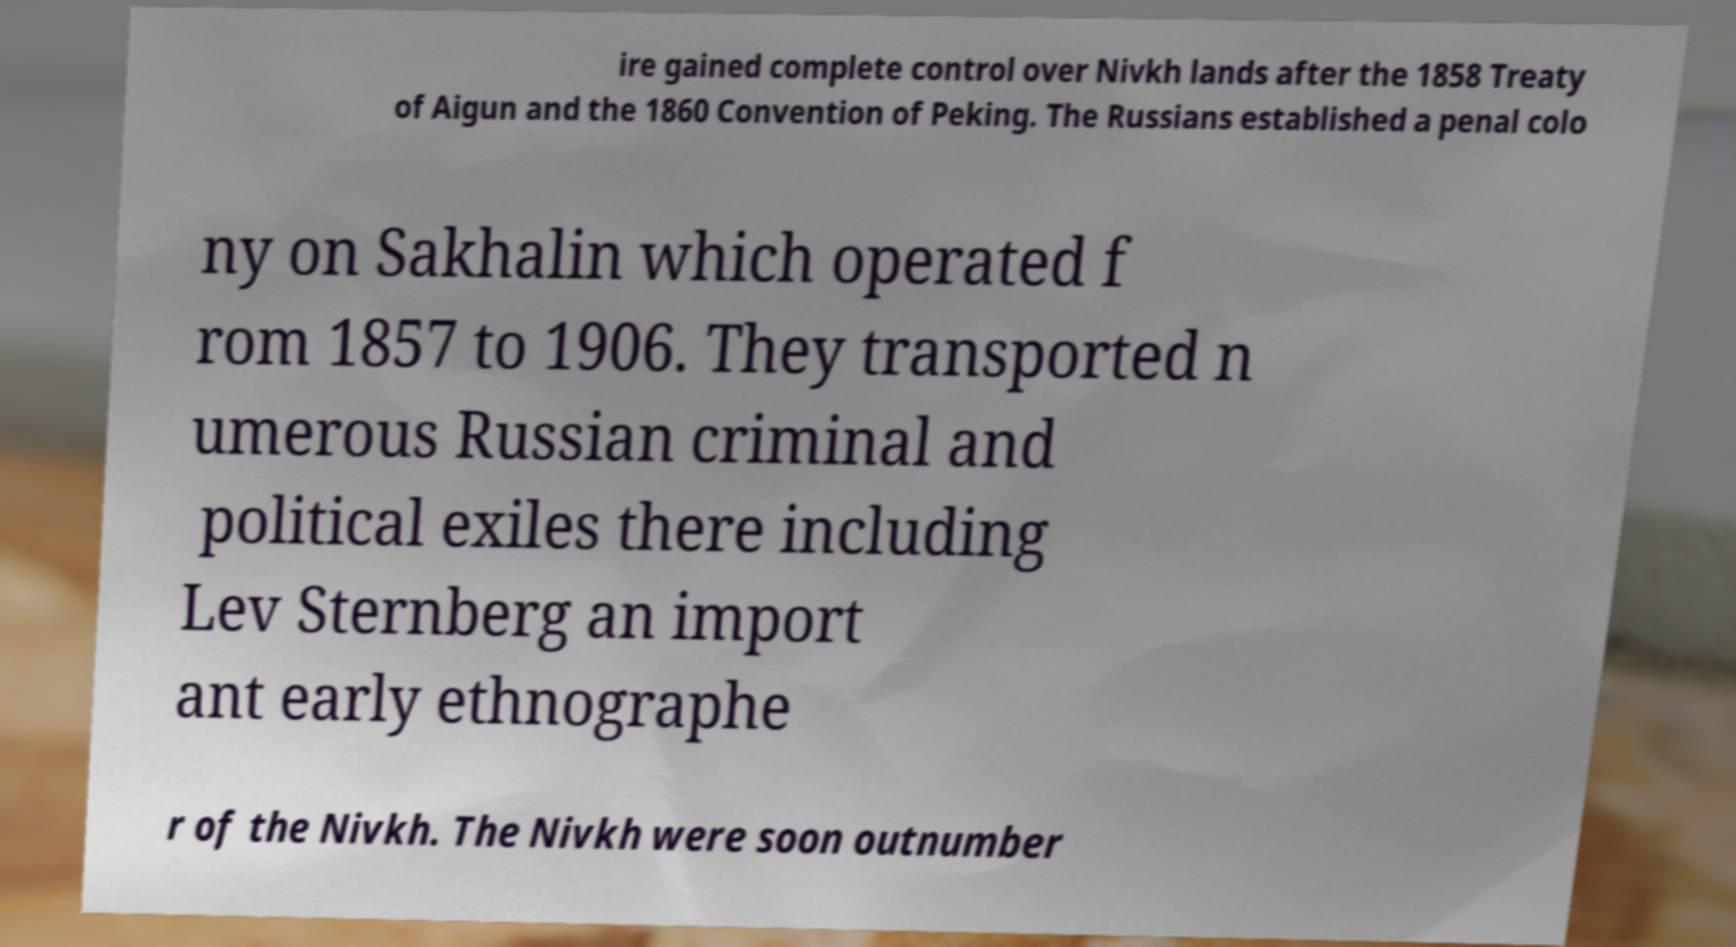Could you assist in decoding the text presented in this image and type it out clearly? ire gained complete control over Nivkh lands after the 1858 Treaty of Aigun and the 1860 Convention of Peking. The Russians established a penal colo ny on Sakhalin which operated f rom 1857 to 1906. They transported n umerous Russian criminal and political exiles there including Lev Sternberg an import ant early ethnographe r of the Nivkh. The Nivkh were soon outnumber 